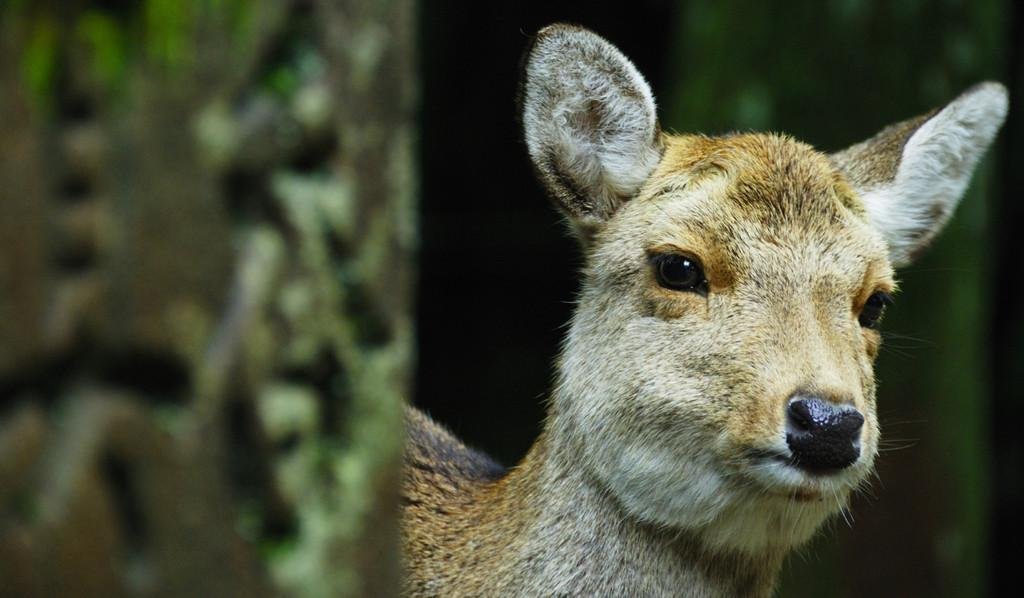What type of creature is present in the image? There is an animal in the image. Can you describe the color of the animal? The animal is in light brown color. How would you describe the background of the image? The background of the image is blurry. What type of map is visible in the image? There is no map present in the image; it features an animal in light brown color with a blurry background. 